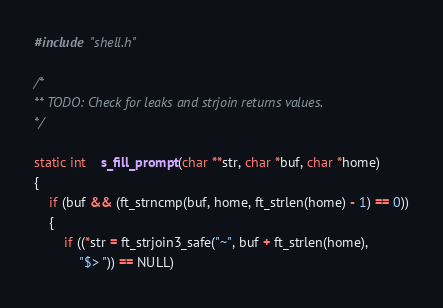<code> <loc_0><loc_0><loc_500><loc_500><_C_>#include "shell.h"

/*
** TODO: Check for leaks and strjoin returns values.
*/

static int	s_fill_prompt(char **str, char *buf, char *home)
{
	if (buf && (ft_strncmp(buf, home, ft_strlen(home) - 1) == 0))
	{
		if ((*str = ft_strjoin3_safe("~", buf + ft_strlen(home),
			"$> ")) == NULL)</code> 